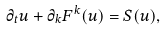<formula> <loc_0><loc_0><loc_500><loc_500>\partial _ { t } u + \partial _ { k } F ^ { k } ( u ) = S ( u ) ,</formula> 